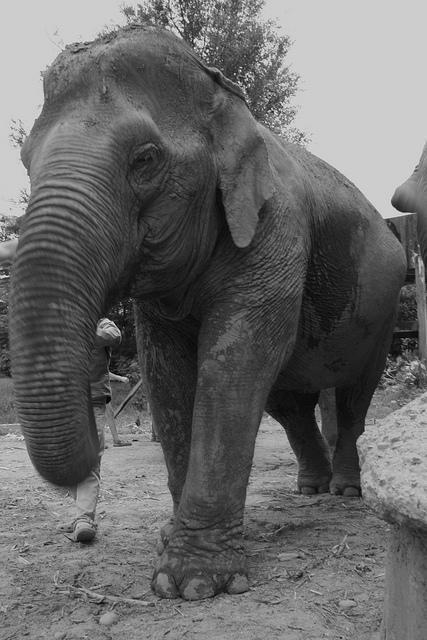How many elephant is in the picture?
Give a very brief answer. 1. 